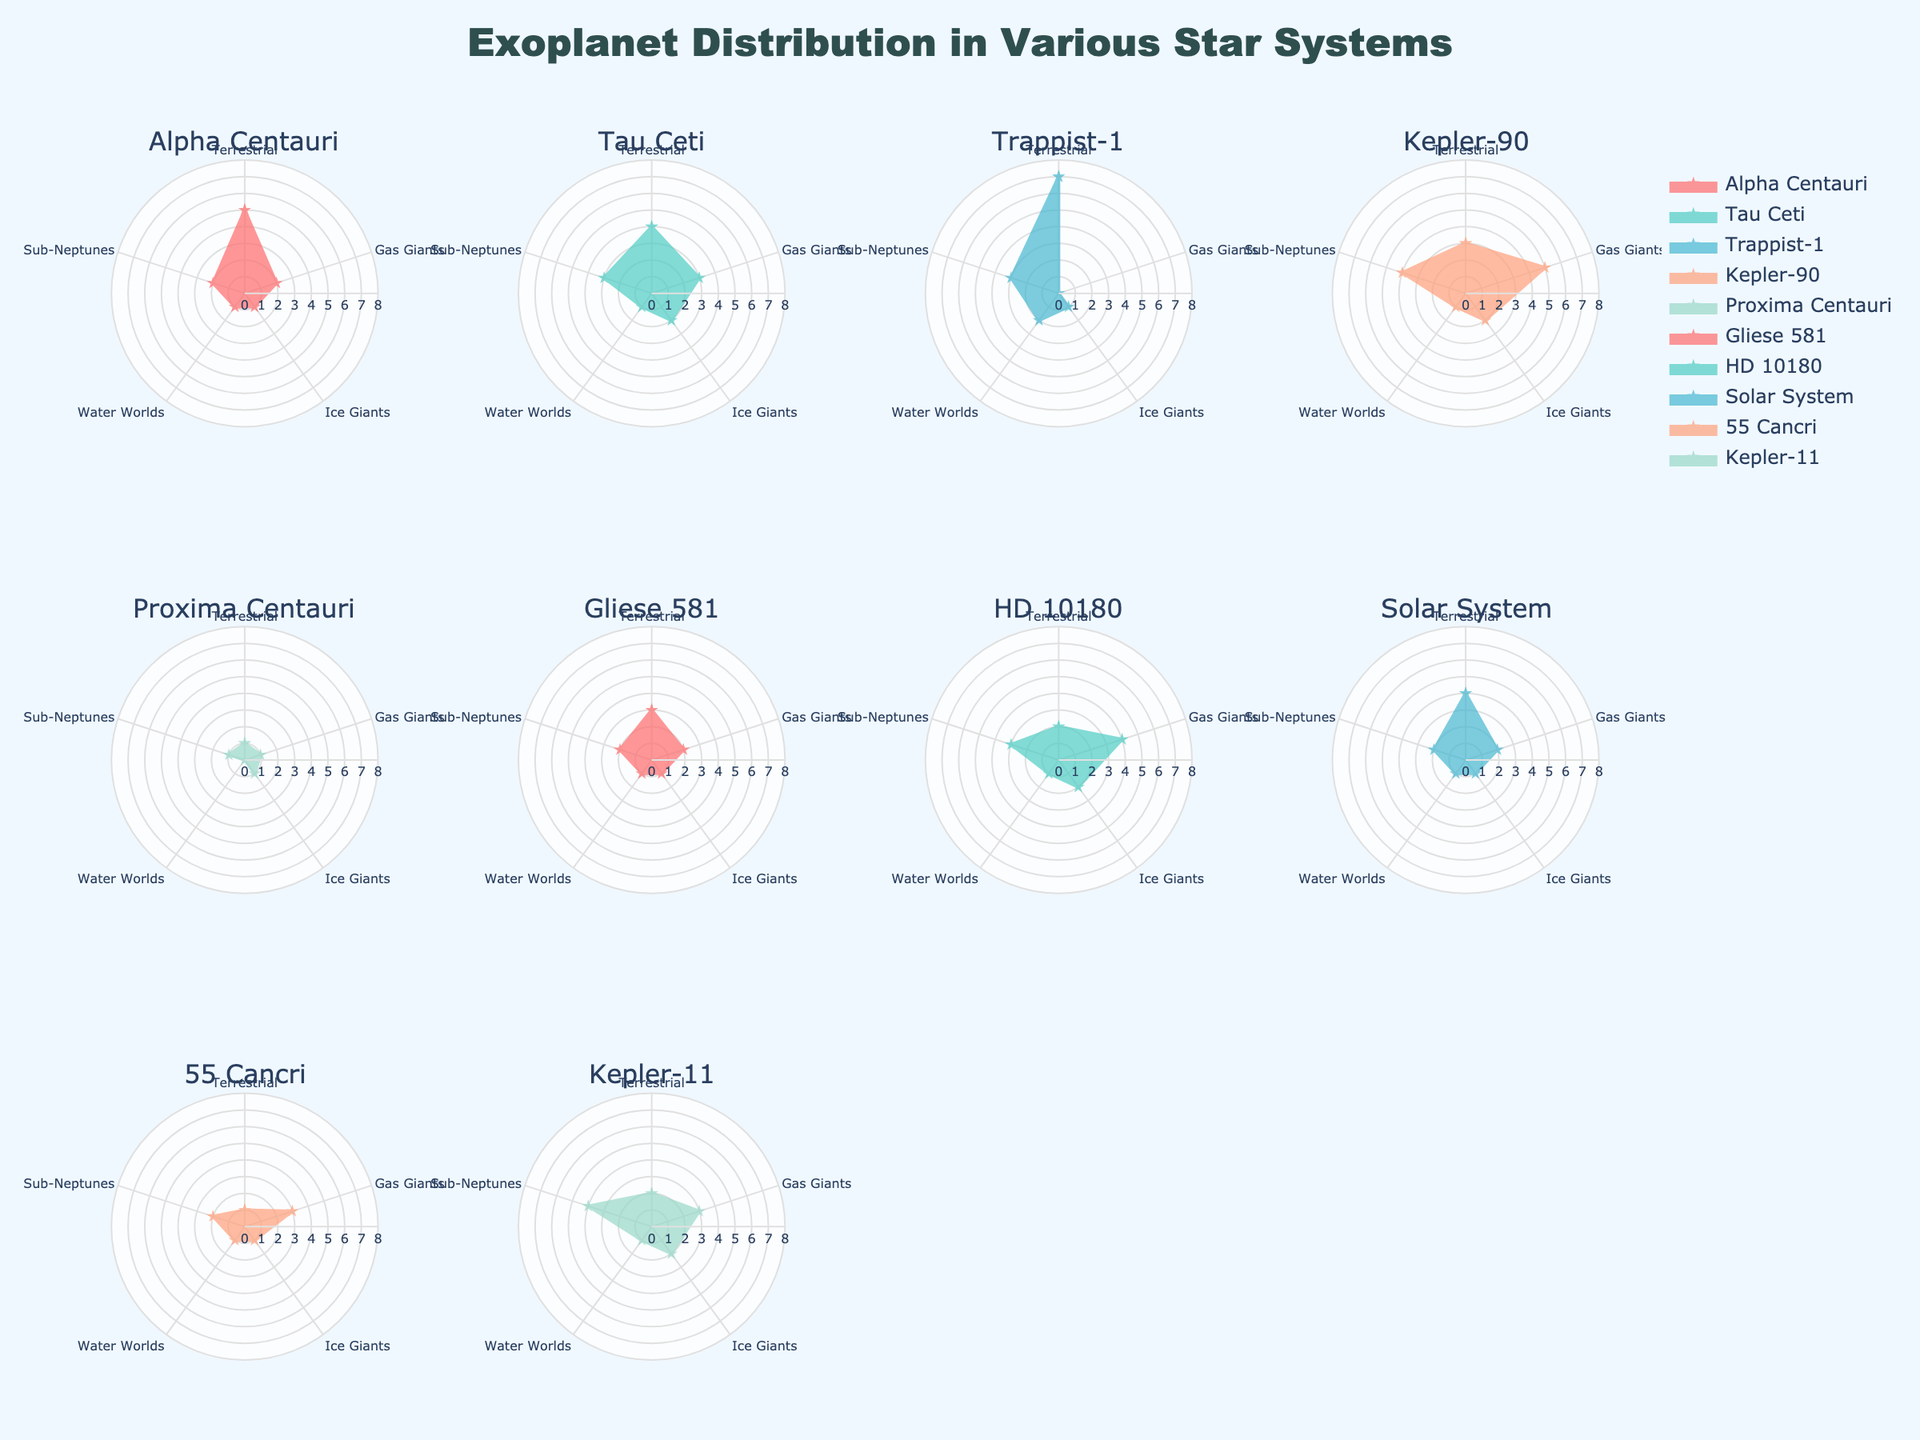What is the title of the figure? The title is typically displayed at the top of the figure, and in this case, it reads "Exoplanet Distribution in Various Star Systems."
Answer: Exoplanet Distribution in Various Star Systems Which star system has the highest number of terrestrial exoplanets? By observing the radar charts, each section represents a different type of exoplanet. The terrestrial section is the first one, and the radar chart for Trappist-1 shows the highest value in this section, which is 7.
Answer: Trappist-1 How many gas giants are there in the Kepler-90 system? The second section of the radar chart indicates the number of gas giants. For Kepler-90, this section extends to the value 5.
Answer: 5 What is the range of values depicted on the radial axis of the plots? The radial axis represents the quantity of each type of exoplanet and ranges from 0 to 8, as indicated near each chart.
Answer: 0 to 8 Which two star systems have the same distribution for terrestrial, gas giants, and ice giants? Upon examining the radar charts, the Solar System and Gliese 581 have similar values for terrestrial (4), gas giants (2), and ice giants (1).
Answer: Solar System and Gliese 581 What is the average number of sub-Neptunes across all star systems? To find the average, add the number of sub-Neptunes for all star systems and divide by the number of systems. (2+3+3+4+1+2+3+2+2+4)/10 = 2.6
Answer: 2.6 Which star system has the lowest number of exoplanet types combined? By summing the values of each type for every star system, Proxima Centauri has the lowest total: 1 + 1 + 1 + 0 + 1 = 4.
Answer: Proxima Centauri How many more terrestrial exoplanets are there in Trappist-1 compared to Proxima Centauri? Trappist-1 has 7 terrestrial exoplanets, while Proxima Centauri has 1. Therefore, the difference is 7 - 1 = 6.
Answer: 6 Which star system has the most balanced distribution of exoplanet types? A balanced distribution would show similar values across all categories. By looking at the radar charts, Kepler-90 displays a balanced distribution with values 3, 5, 2, 1, and 4.
Answer: Kepler-90 